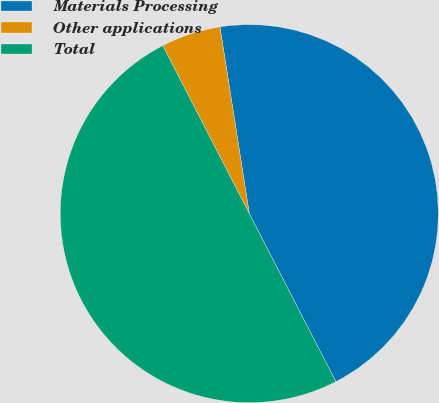<chart> <loc_0><loc_0><loc_500><loc_500><pie_chart><fcel>Materials Processing<fcel>Other applications<fcel>Total<nl><fcel>44.91%<fcel>5.09%<fcel>50.0%<nl></chart> 